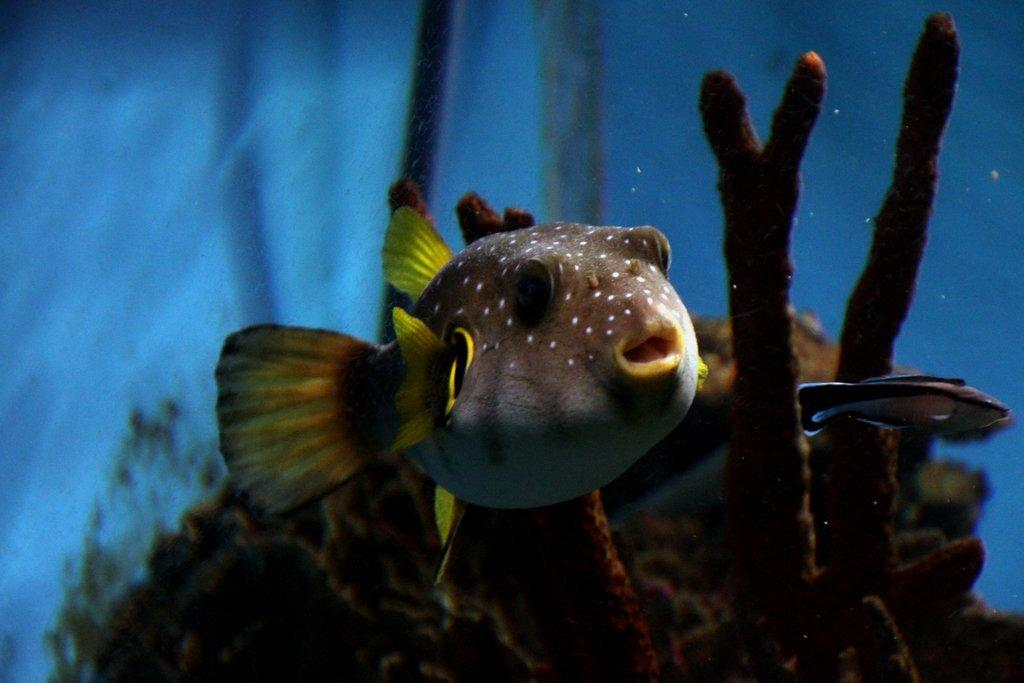What type of animals can be seen in the image? There are fishes in the image. What are the fishes doing in the image? The fishes are swimming in the water. What type of board can be seen in the image? There is no board present in the image; it features fishes swimming in the water. How many chickens are visible in the image? There are no chickens present in the image. 